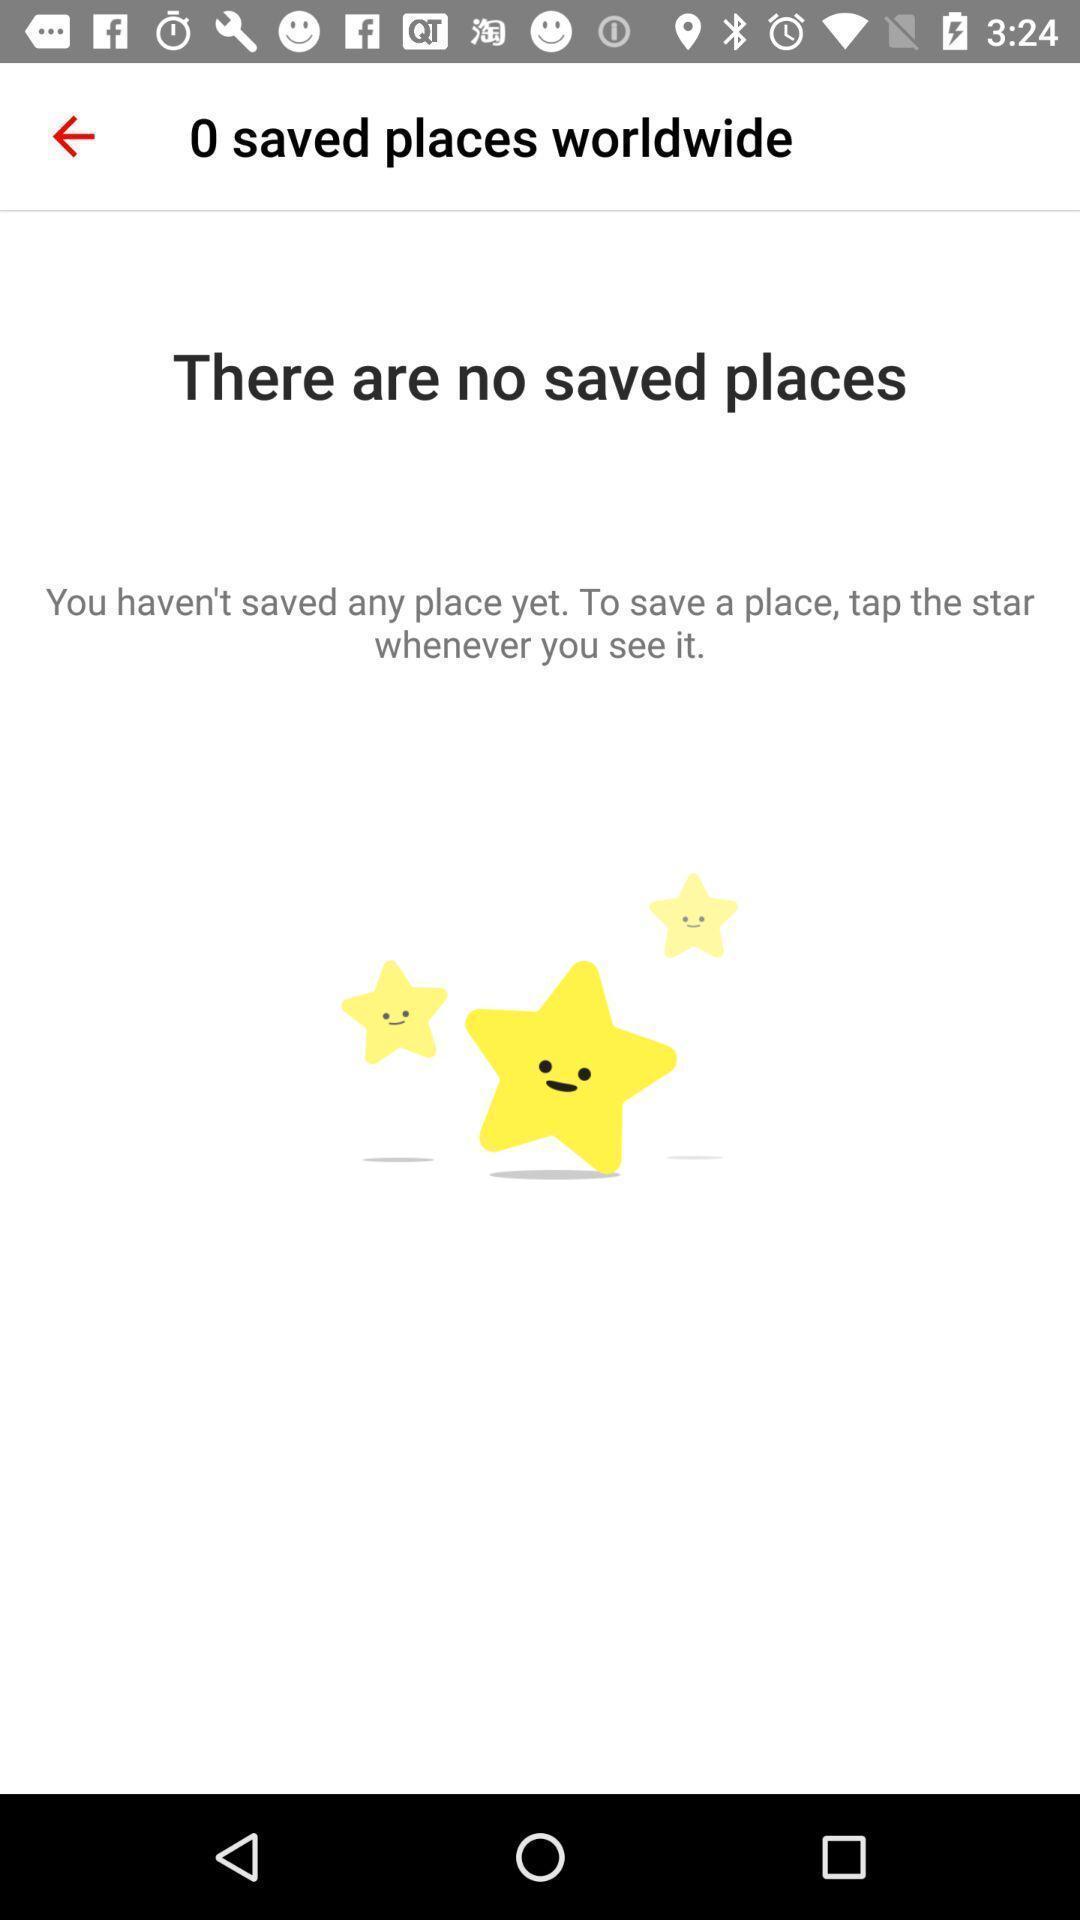Tell me what you see in this picture. Screen showing the blank page no saved places. 